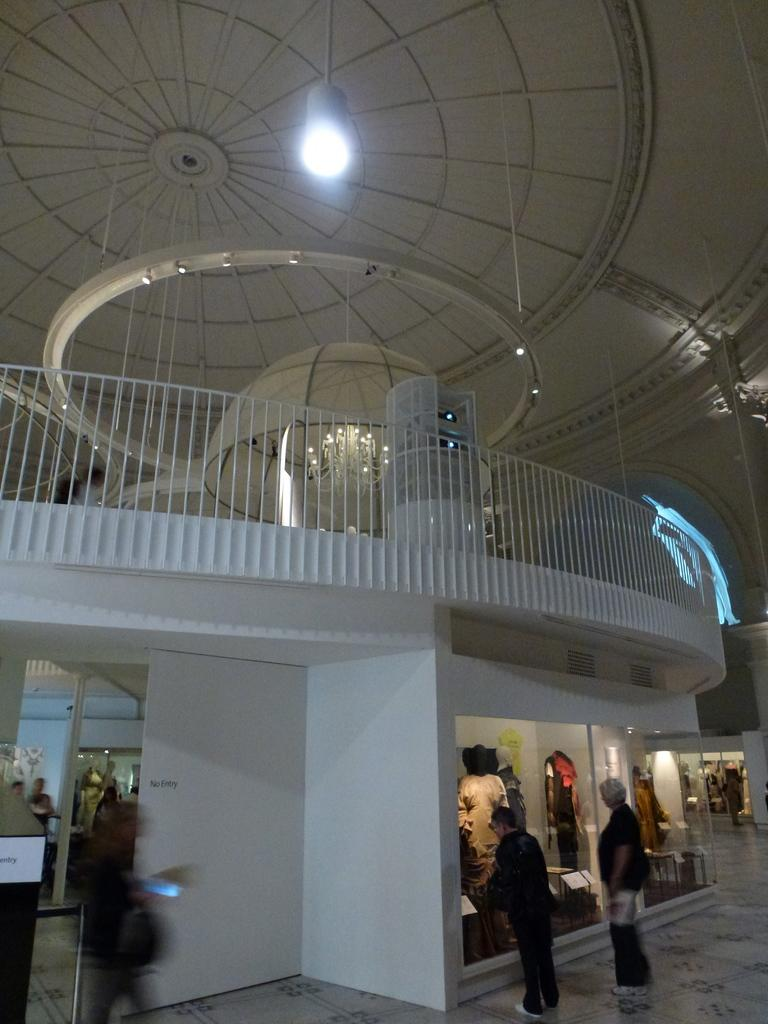How many people are visible in the image? There are people standing in the image. What surface are the people standing on? The people are standing on the floor. What type of walls can be seen in the image? There are glass walls in the image. What architectural feature is present in the image? There is a fence in the image. What type of lighting is present in the image? There are lights in the image. What is the location of the image? The image is an inside view of a building. What type of cloud can be seen through the glass walls in the image? There are no clouds visible in the image, as it is an inside view of a building with glass walls. What hobbies are the people engaging in while standing in the image? The provided facts do not mention any specific hobbies or activities that the people are engaged in. 